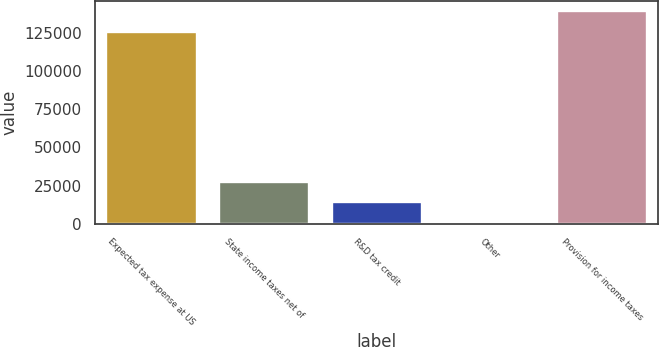Convert chart to OTSL. <chart><loc_0><loc_0><loc_500><loc_500><bar_chart><fcel>Expected tax expense at US<fcel>State income taxes net of<fcel>R&D tax credit<fcel>Other<fcel>Provision for income taxes<nl><fcel>125833<fcel>27388<fcel>14137<fcel>886<fcel>139084<nl></chart> 